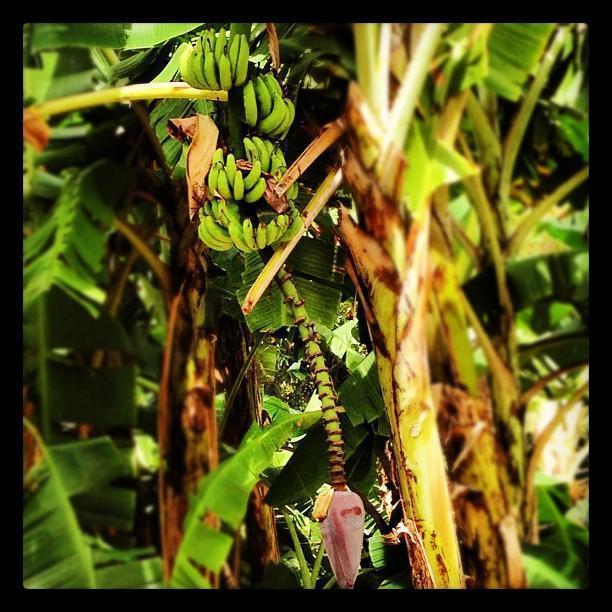Why are the bananas green?
Make your selection from the four choices given to correctly answer the question.
Options: Stained, ripe, painted, unripe. Unripe. 